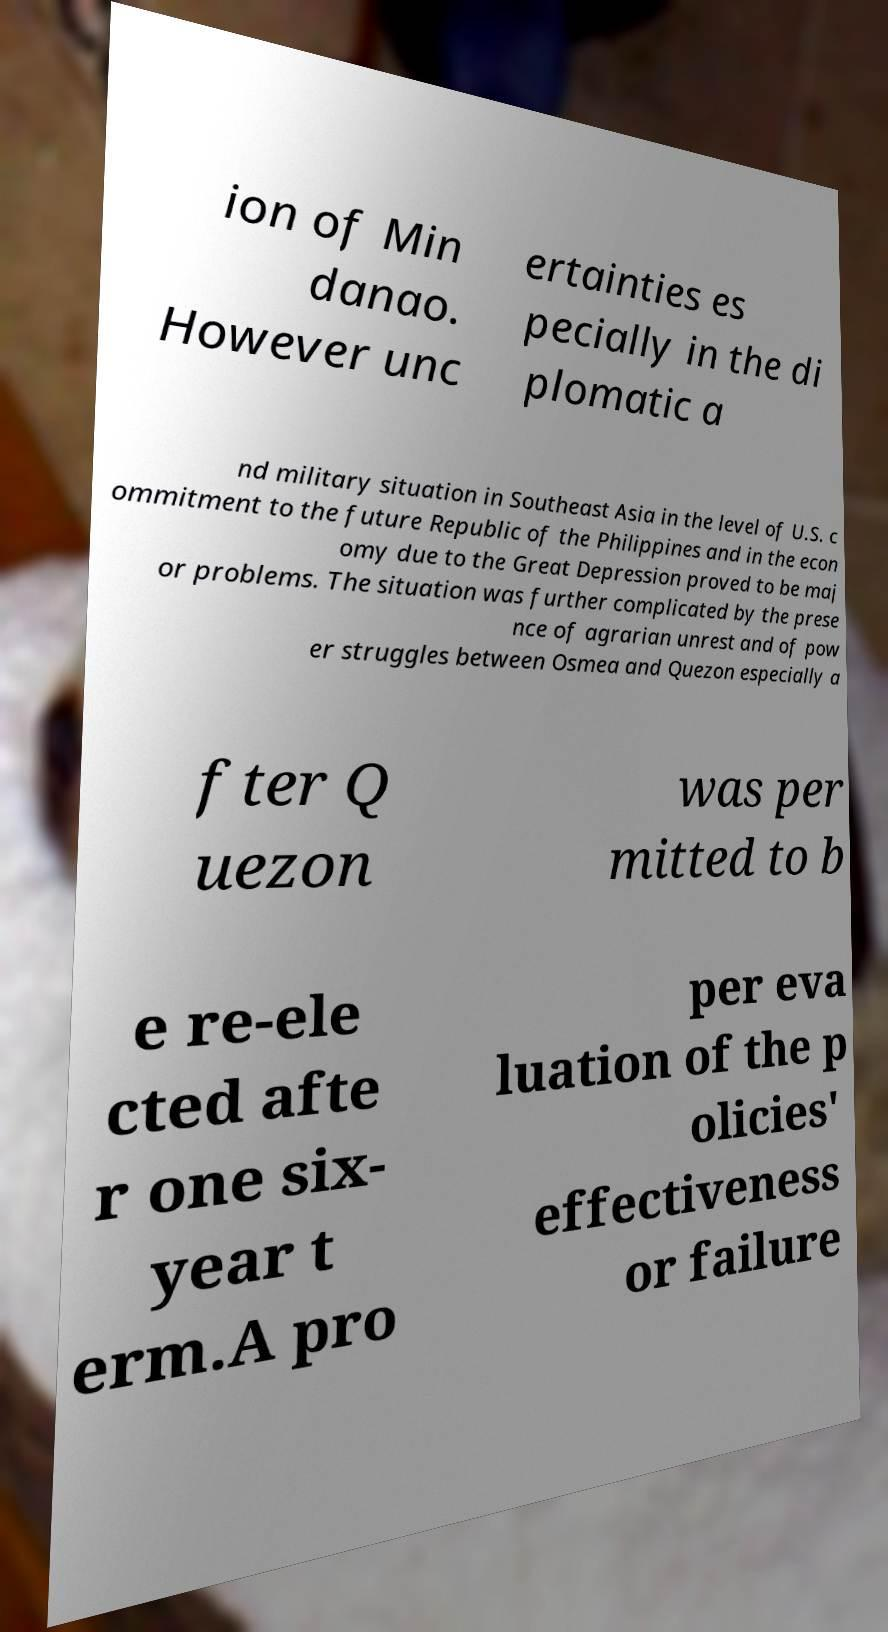Could you assist in decoding the text presented in this image and type it out clearly? ion of Min danao. However unc ertainties es pecially in the di plomatic a nd military situation in Southeast Asia in the level of U.S. c ommitment to the future Republic of the Philippines and in the econ omy due to the Great Depression proved to be maj or problems. The situation was further complicated by the prese nce of agrarian unrest and of pow er struggles between Osmea and Quezon especially a fter Q uezon was per mitted to b e re-ele cted afte r one six- year t erm.A pro per eva luation of the p olicies' effectiveness or failure 